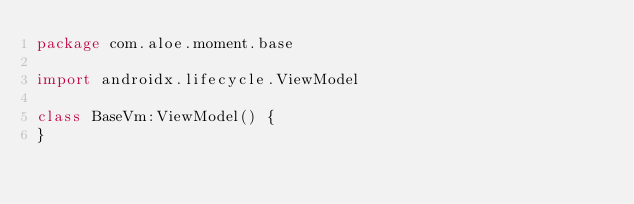Convert code to text. <code><loc_0><loc_0><loc_500><loc_500><_Kotlin_>package com.aloe.moment.base

import androidx.lifecycle.ViewModel

class BaseVm:ViewModel() {
}</code> 